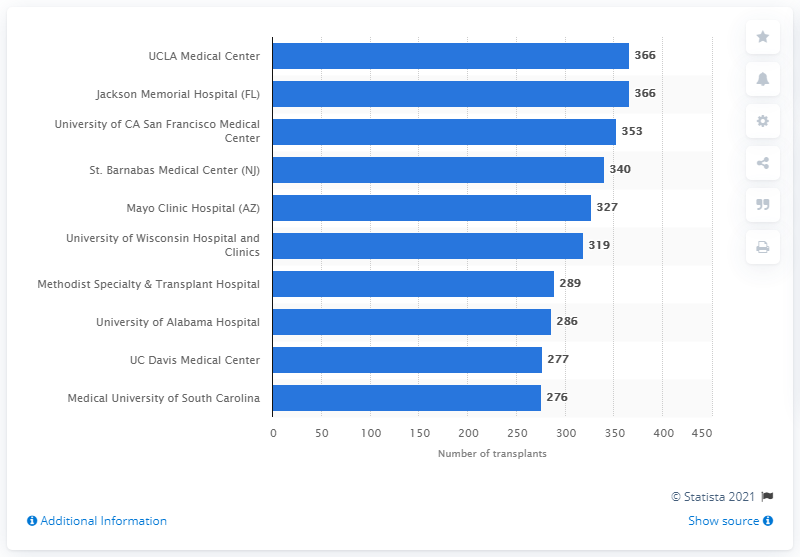Specify some key components in this picture. In 2017, the University of California San Francisco Medical Center performed 353 kidney transplants. 